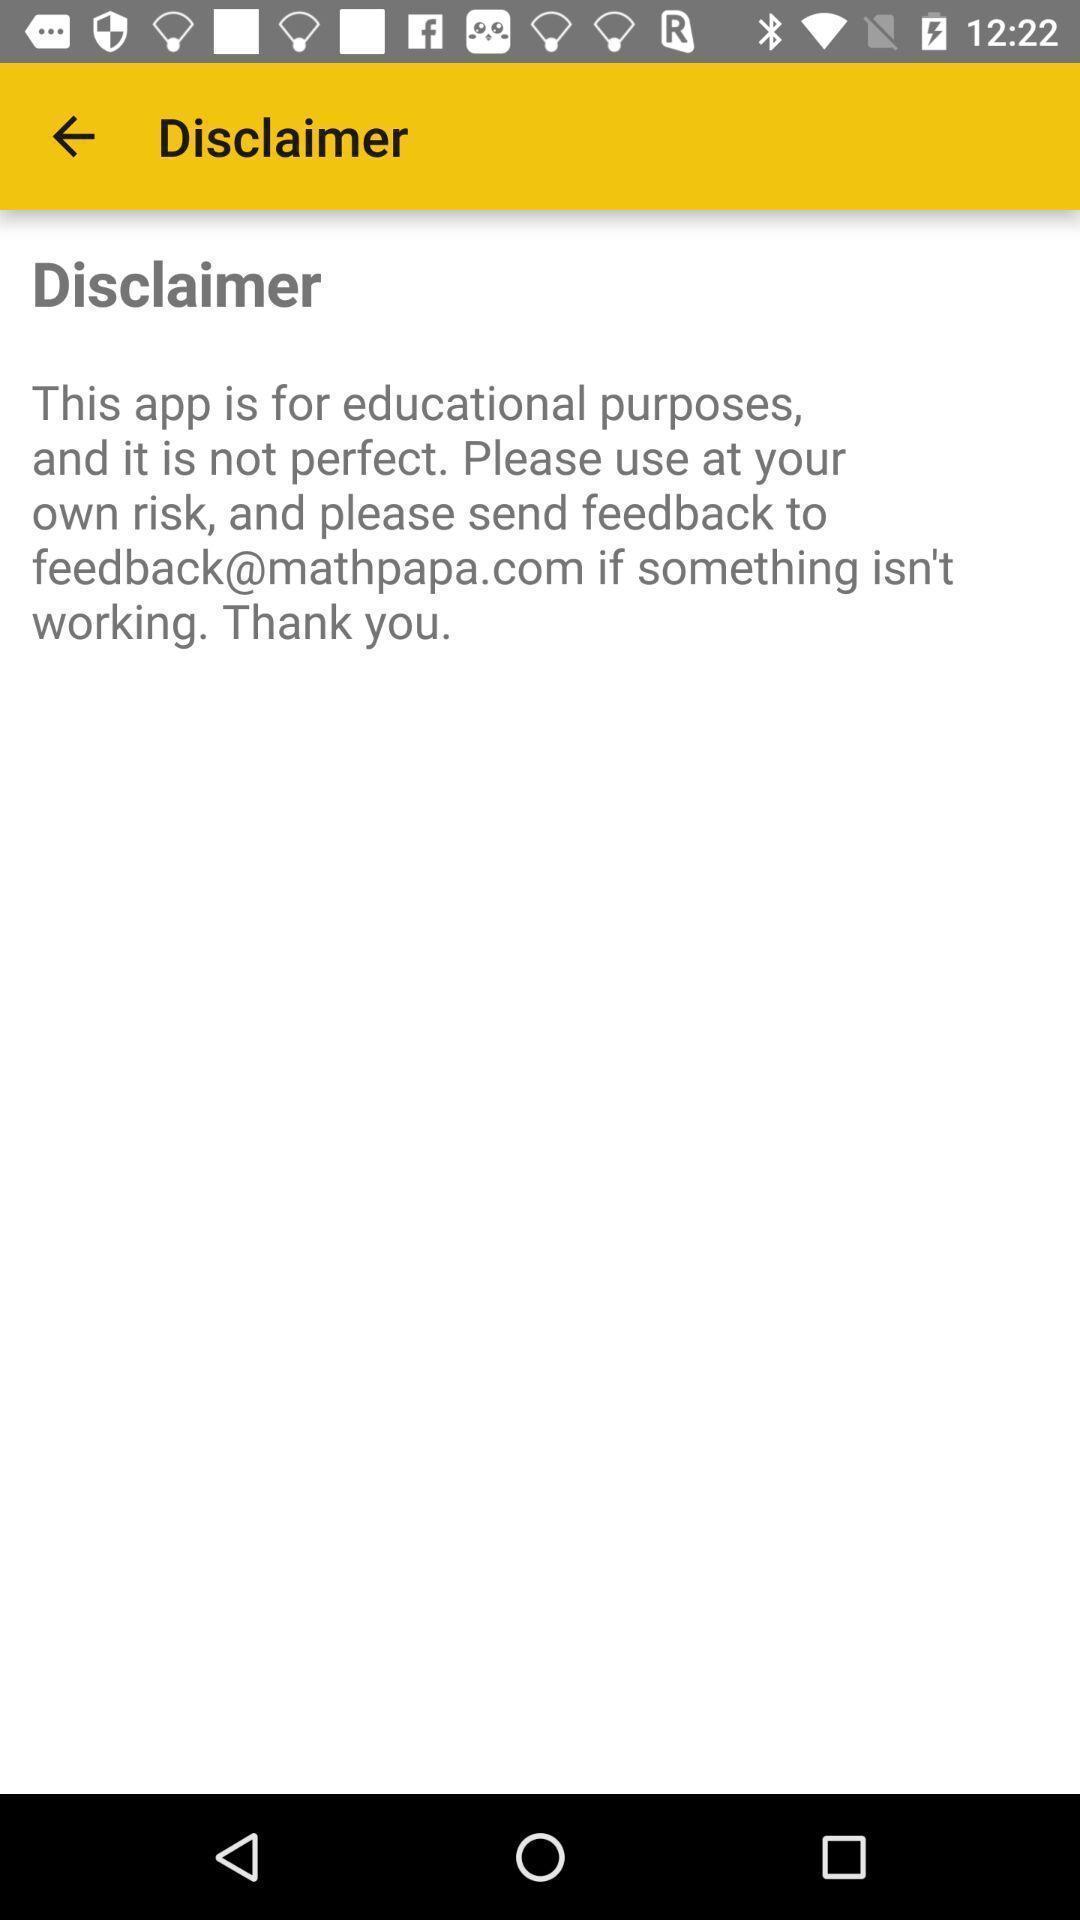Describe the content in this image. Page showing disclaimer. 